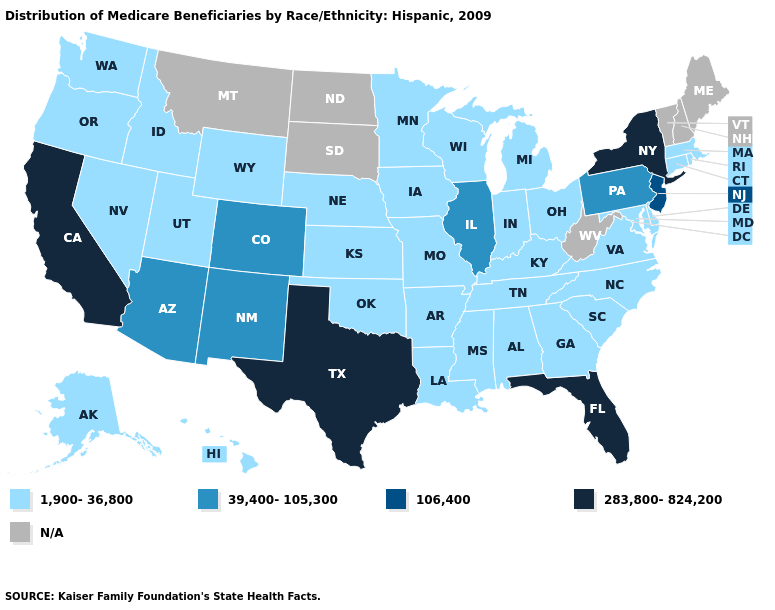What is the value of Pennsylvania?
Concise answer only. 39,400-105,300. What is the value of Arkansas?
Short answer required. 1,900-36,800. Among the states that border Utah , which have the highest value?
Quick response, please. Arizona, Colorado, New Mexico. Does the first symbol in the legend represent the smallest category?
Keep it brief. Yes. Among the states that border South Carolina , which have the highest value?
Keep it brief. Georgia, North Carolina. Among the states that border Arizona , does Nevada have the lowest value?
Concise answer only. Yes. Does New Jersey have the lowest value in the Northeast?
Answer briefly. No. Name the states that have a value in the range 106,400?
Quick response, please. New Jersey. Which states have the highest value in the USA?
Give a very brief answer. California, Florida, New York, Texas. What is the value of Oregon?
Answer briefly. 1,900-36,800. Which states have the lowest value in the Northeast?
Short answer required. Connecticut, Massachusetts, Rhode Island. What is the lowest value in states that border Montana?
Concise answer only. 1,900-36,800. What is the highest value in the USA?
Keep it brief. 283,800-824,200. Which states have the lowest value in the Northeast?
Short answer required. Connecticut, Massachusetts, Rhode Island. What is the value of Montana?
Concise answer only. N/A. 